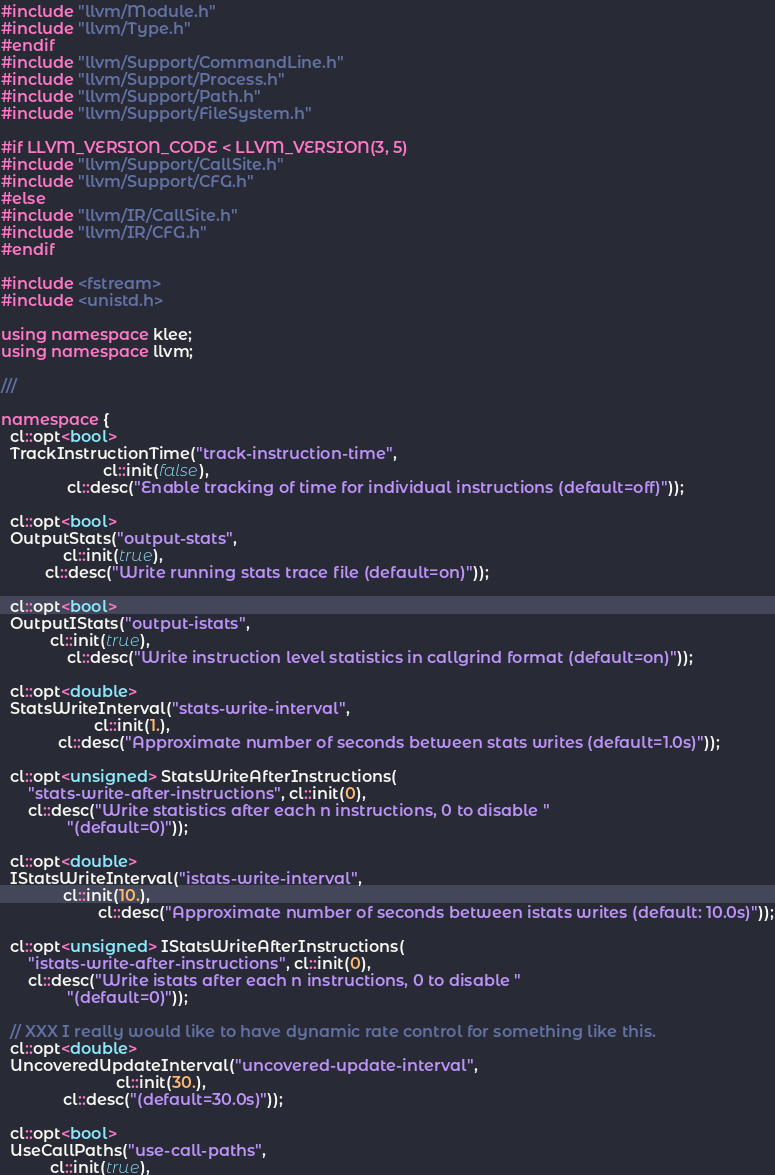<code> <loc_0><loc_0><loc_500><loc_500><_C++_>#include "llvm/Module.h"
#include "llvm/Type.h"
#endif
#include "llvm/Support/CommandLine.h"
#include "llvm/Support/Process.h"
#include "llvm/Support/Path.h"
#include "llvm/Support/FileSystem.h"

#if LLVM_VERSION_CODE < LLVM_VERSION(3, 5)
#include "llvm/Support/CallSite.h"
#include "llvm/Support/CFG.h"
#else
#include "llvm/IR/CallSite.h"
#include "llvm/IR/CFG.h"
#endif

#include <fstream>
#include <unistd.h>

using namespace klee;
using namespace llvm;

///

namespace {  
  cl::opt<bool>
  TrackInstructionTime("track-instruction-time",
                       cl::init(false),
		       cl::desc("Enable tracking of time for individual instructions (default=off)"));

  cl::opt<bool>
  OutputStats("output-stats",
              cl::init(true),
	      cl::desc("Write running stats trace file (default=on)"));

  cl::opt<bool>
  OutputIStats("output-istats",
	       cl::init(true),
               cl::desc("Write instruction level statistics in callgrind format (default=on)"));

  cl::opt<double>
  StatsWriteInterval("stats-write-interval",
                     cl::init(1.),
		     cl::desc("Approximate number of seconds between stats writes (default=1.0s)"));

  cl::opt<unsigned> StatsWriteAfterInstructions(
      "stats-write-after-instructions", cl::init(0),
      cl::desc("Write statistics after each n instructions, 0 to disable "
               "(default=0)"));

  cl::opt<double>
  IStatsWriteInterval("istats-write-interval",
		      cl::init(10.),
                      cl::desc("Approximate number of seconds between istats writes (default: 10.0s)"));

  cl::opt<unsigned> IStatsWriteAfterInstructions(
      "istats-write-after-instructions", cl::init(0),
      cl::desc("Write istats after each n instructions, 0 to disable "
               "(default=0)"));

  // XXX I really would like to have dynamic rate control for something like this.
  cl::opt<double>
  UncoveredUpdateInterval("uncovered-update-interval",
                          cl::init(30.),
			  cl::desc("(default=30.0s)"));
  
  cl::opt<bool>
  UseCallPaths("use-call-paths",
	       cl::init(true),</code> 